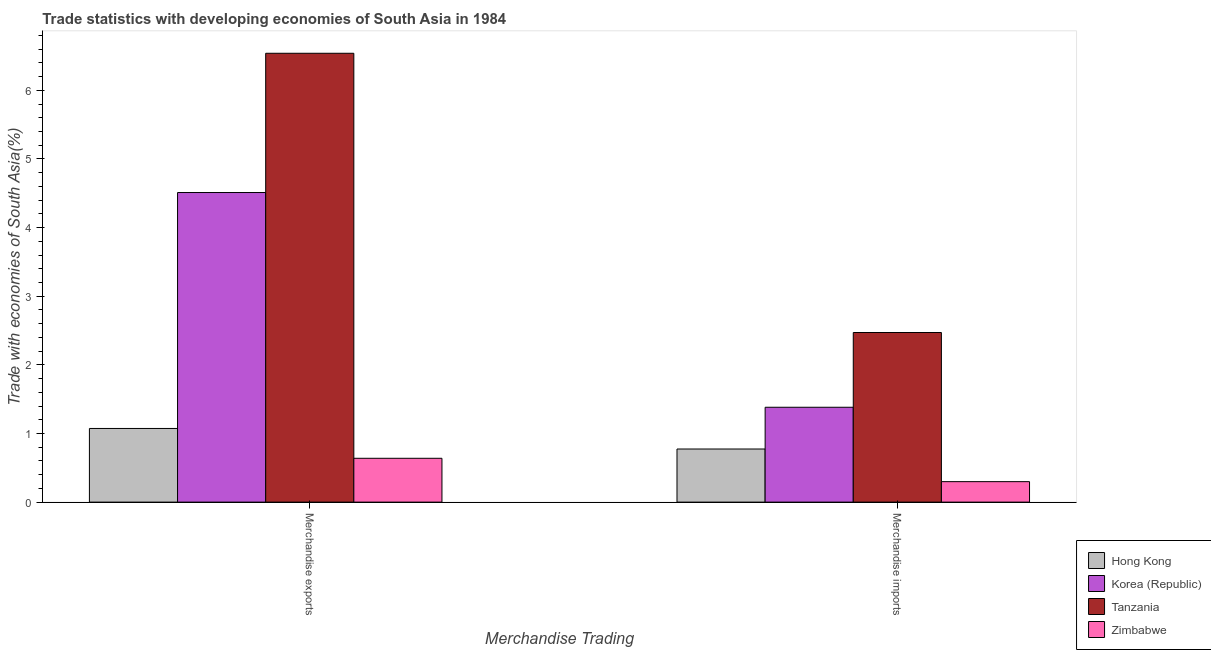Are the number of bars on each tick of the X-axis equal?
Your response must be concise. Yes. How many bars are there on the 1st tick from the right?
Give a very brief answer. 4. What is the merchandise exports in Korea (Republic)?
Offer a very short reply. 4.51. Across all countries, what is the maximum merchandise imports?
Offer a very short reply. 2.47. Across all countries, what is the minimum merchandise imports?
Your answer should be compact. 0.3. In which country was the merchandise imports maximum?
Your answer should be compact. Tanzania. In which country was the merchandise imports minimum?
Make the answer very short. Zimbabwe. What is the total merchandise exports in the graph?
Offer a terse response. 12.76. What is the difference between the merchandise exports in Hong Kong and that in Zimbabwe?
Your answer should be very brief. 0.43. What is the difference between the merchandise imports in Zimbabwe and the merchandise exports in Korea (Republic)?
Provide a succinct answer. -4.21. What is the average merchandise exports per country?
Your answer should be very brief. 3.19. What is the difference between the merchandise exports and merchandise imports in Zimbabwe?
Your response must be concise. 0.34. In how many countries, is the merchandise imports greater than 3.6 %?
Provide a succinct answer. 0. What is the ratio of the merchandise imports in Hong Kong to that in Tanzania?
Provide a short and direct response. 0.31. Is the merchandise exports in Zimbabwe less than that in Tanzania?
Provide a short and direct response. Yes. In how many countries, is the merchandise exports greater than the average merchandise exports taken over all countries?
Ensure brevity in your answer.  2. What does the 4th bar from the left in Merchandise imports represents?
Offer a very short reply. Zimbabwe. What does the 1st bar from the right in Merchandise imports represents?
Your answer should be compact. Zimbabwe. Does the graph contain grids?
Provide a succinct answer. No. How many legend labels are there?
Give a very brief answer. 4. How are the legend labels stacked?
Give a very brief answer. Vertical. What is the title of the graph?
Offer a very short reply. Trade statistics with developing economies of South Asia in 1984. Does "Egypt, Arab Rep." appear as one of the legend labels in the graph?
Your answer should be compact. No. What is the label or title of the X-axis?
Give a very brief answer. Merchandise Trading. What is the label or title of the Y-axis?
Give a very brief answer. Trade with economies of South Asia(%). What is the Trade with economies of South Asia(%) of Hong Kong in Merchandise exports?
Keep it short and to the point. 1.07. What is the Trade with economies of South Asia(%) of Korea (Republic) in Merchandise exports?
Your response must be concise. 4.51. What is the Trade with economies of South Asia(%) in Tanzania in Merchandise exports?
Provide a short and direct response. 6.54. What is the Trade with economies of South Asia(%) of Zimbabwe in Merchandise exports?
Your response must be concise. 0.64. What is the Trade with economies of South Asia(%) of Hong Kong in Merchandise imports?
Provide a short and direct response. 0.77. What is the Trade with economies of South Asia(%) in Korea (Republic) in Merchandise imports?
Provide a succinct answer. 1.38. What is the Trade with economies of South Asia(%) of Tanzania in Merchandise imports?
Keep it short and to the point. 2.47. What is the Trade with economies of South Asia(%) in Zimbabwe in Merchandise imports?
Provide a succinct answer. 0.3. Across all Merchandise Trading, what is the maximum Trade with economies of South Asia(%) of Hong Kong?
Offer a very short reply. 1.07. Across all Merchandise Trading, what is the maximum Trade with economies of South Asia(%) in Korea (Republic)?
Offer a very short reply. 4.51. Across all Merchandise Trading, what is the maximum Trade with economies of South Asia(%) of Tanzania?
Give a very brief answer. 6.54. Across all Merchandise Trading, what is the maximum Trade with economies of South Asia(%) of Zimbabwe?
Make the answer very short. 0.64. Across all Merchandise Trading, what is the minimum Trade with economies of South Asia(%) of Hong Kong?
Your answer should be very brief. 0.77. Across all Merchandise Trading, what is the minimum Trade with economies of South Asia(%) in Korea (Republic)?
Your answer should be very brief. 1.38. Across all Merchandise Trading, what is the minimum Trade with economies of South Asia(%) in Tanzania?
Provide a short and direct response. 2.47. Across all Merchandise Trading, what is the minimum Trade with economies of South Asia(%) in Zimbabwe?
Ensure brevity in your answer.  0.3. What is the total Trade with economies of South Asia(%) of Hong Kong in the graph?
Ensure brevity in your answer.  1.85. What is the total Trade with economies of South Asia(%) of Korea (Republic) in the graph?
Provide a succinct answer. 5.89. What is the total Trade with economies of South Asia(%) in Tanzania in the graph?
Keep it short and to the point. 9.01. What is the total Trade with economies of South Asia(%) in Zimbabwe in the graph?
Provide a short and direct response. 0.94. What is the difference between the Trade with economies of South Asia(%) of Hong Kong in Merchandise exports and that in Merchandise imports?
Give a very brief answer. 0.3. What is the difference between the Trade with economies of South Asia(%) of Korea (Republic) in Merchandise exports and that in Merchandise imports?
Your response must be concise. 3.13. What is the difference between the Trade with economies of South Asia(%) of Tanzania in Merchandise exports and that in Merchandise imports?
Your answer should be very brief. 4.07. What is the difference between the Trade with economies of South Asia(%) of Zimbabwe in Merchandise exports and that in Merchandise imports?
Your response must be concise. 0.34. What is the difference between the Trade with economies of South Asia(%) of Hong Kong in Merchandise exports and the Trade with economies of South Asia(%) of Korea (Republic) in Merchandise imports?
Give a very brief answer. -0.31. What is the difference between the Trade with economies of South Asia(%) of Hong Kong in Merchandise exports and the Trade with economies of South Asia(%) of Tanzania in Merchandise imports?
Your response must be concise. -1.4. What is the difference between the Trade with economies of South Asia(%) in Hong Kong in Merchandise exports and the Trade with economies of South Asia(%) in Zimbabwe in Merchandise imports?
Make the answer very short. 0.78. What is the difference between the Trade with economies of South Asia(%) of Korea (Republic) in Merchandise exports and the Trade with economies of South Asia(%) of Tanzania in Merchandise imports?
Keep it short and to the point. 2.04. What is the difference between the Trade with economies of South Asia(%) in Korea (Republic) in Merchandise exports and the Trade with economies of South Asia(%) in Zimbabwe in Merchandise imports?
Provide a short and direct response. 4.21. What is the difference between the Trade with economies of South Asia(%) of Tanzania in Merchandise exports and the Trade with economies of South Asia(%) of Zimbabwe in Merchandise imports?
Give a very brief answer. 6.24. What is the average Trade with economies of South Asia(%) of Hong Kong per Merchandise Trading?
Make the answer very short. 0.92. What is the average Trade with economies of South Asia(%) in Korea (Republic) per Merchandise Trading?
Your answer should be very brief. 2.95. What is the average Trade with economies of South Asia(%) of Tanzania per Merchandise Trading?
Make the answer very short. 4.51. What is the average Trade with economies of South Asia(%) of Zimbabwe per Merchandise Trading?
Your answer should be compact. 0.47. What is the difference between the Trade with economies of South Asia(%) in Hong Kong and Trade with economies of South Asia(%) in Korea (Republic) in Merchandise exports?
Ensure brevity in your answer.  -3.44. What is the difference between the Trade with economies of South Asia(%) of Hong Kong and Trade with economies of South Asia(%) of Tanzania in Merchandise exports?
Provide a short and direct response. -5.47. What is the difference between the Trade with economies of South Asia(%) in Hong Kong and Trade with economies of South Asia(%) in Zimbabwe in Merchandise exports?
Your response must be concise. 0.43. What is the difference between the Trade with economies of South Asia(%) in Korea (Republic) and Trade with economies of South Asia(%) in Tanzania in Merchandise exports?
Offer a very short reply. -2.03. What is the difference between the Trade with economies of South Asia(%) of Korea (Republic) and Trade with economies of South Asia(%) of Zimbabwe in Merchandise exports?
Provide a succinct answer. 3.87. What is the difference between the Trade with economies of South Asia(%) of Tanzania and Trade with economies of South Asia(%) of Zimbabwe in Merchandise exports?
Offer a terse response. 5.9. What is the difference between the Trade with economies of South Asia(%) of Hong Kong and Trade with economies of South Asia(%) of Korea (Republic) in Merchandise imports?
Ensure brevity in your answer.  -0.61. What is the difference between the Trade with economies of South Asia(%) of Hong Kong and Trade with economies of South Asia(%) of Tanzania in Merchandise imports?
Your response must be concise. -1.7. What is the difference between the Trade with economies of South Asia(%) in Hong Kong and Trade with economies of South Asia(%) in Zimbabwe in Merchandise imports?
Ensure brevity in your answer.  0.48. What is the difference between the Trade with economies of South Asia(%) in Korea (Republic) and Trade with economies of South Asia(%) in Tanzania in Merchandise imports?
Your answer should be compact. -1.09. What is the difference between the Trade with economies of South Asia(%) in Korea (Republic) and Trade with economies of South Asia(%) in Zimbabwe in Merchandise imports?
Make the answer very short. 1.08. What is the difference between the Trade with economies of South Asia(%) in Tanzania and Trade with economies of South Asia(%) in Zimbabwe in Merchandise imports?
Keep it short and to the point. 2.17. What is the ratio of the Trade with economies of South Asia(%) of Hong Kong in Merchandise exports to that in Merchandise imports?
Your answer should be very brief. 1.39. What is the ratio of the Trade with economies of South Asia(%) of Korea (Republic) in Merchandise exports to that in Merchandise imports?
Provide a succinct answer. 3.26. What is the ratio of the Trade with economies of South Asia(%) of Tanzania in Merchandise exports to that in Merchandise imports?
Offer a very short reply. 2.65. What is the ratio of the Trade with economies of South Asia(%) of Zimbabwe in Merchandise exports to that in Merchandise imports?
Keep it short and to the point. 2.14. What is the difference between the highest and the second highest Trade with economies of South Asia(%) of Hong Kong?
Ensure brevity in your answer.  0.3. What is the difference between the highest and the second highest Trade with economies of South Asia(%) in Korea (Republic)?
Your response must be concise. 3.13. What is the difference between the highest and the second highest Trade with economies of South Asia(%) in Tanzania?
Provide a succinct answer. 4.07. What is the difference between the highest and the second highest Trade with economies of South Asia(%) in Zimbabwe?
Offer a very short reply. 0.34. What is the difference between the highest and the lowest Trade with economies of South Asia(%) in Hong Kong?
Make the answer very short. 0.3. What is the difference between the highest and the lowest Trade with economies of South Asia(%) in Korea (Republic)?
Offer a very short reply. 3.13. What is the difference between the highest and the lowest Trade with economies of South Asia(%) in Tanzania?
Ensure brevity in your answer.  4.07. What is the difference between the highest and the lowest Trade with economies of South Asia(%) in Zimbabwe?
Keep it short and to the point. 0.34. 